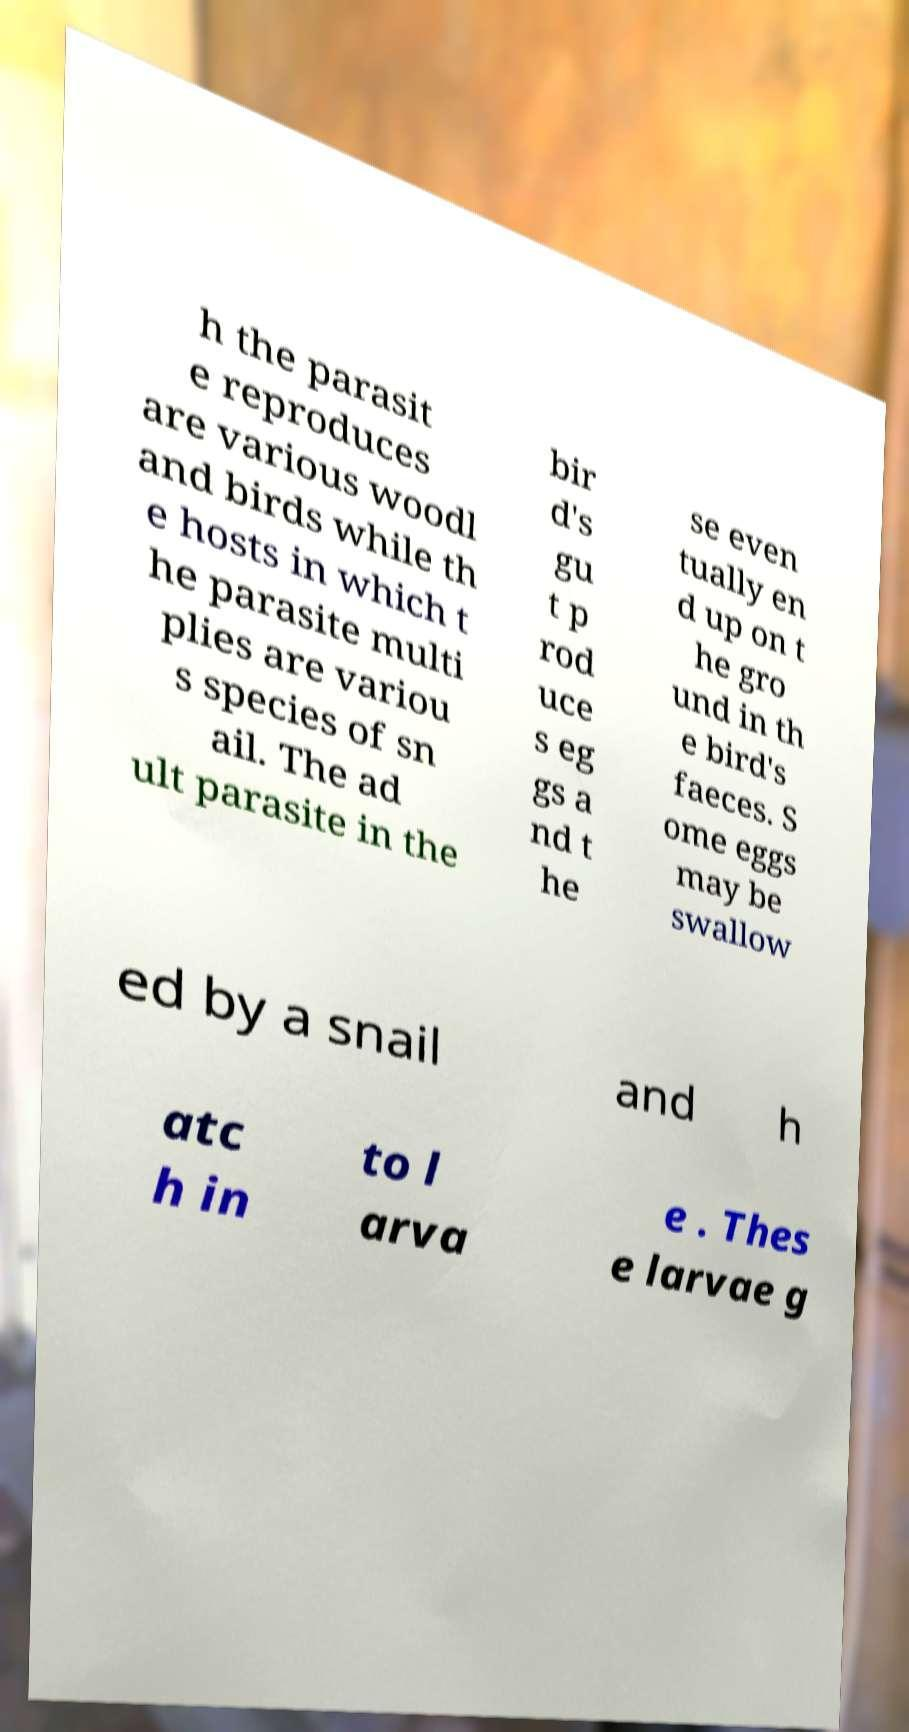What messages or text are displayed in this image? I need them in a readable, typed format. h the parasit e reproduces are various woodl and birds while th e hosts in which t he parasite multi plies are variou s species of sn ail. The ad ult parasite in the bir d's gu t p rod uce s eg gs a nd t he se even tually en d up on t he gro und in th e bird's faeces. S ome eggs may be swallow ed by a snail and h atc h in to l arva e . Thes e larvae g 